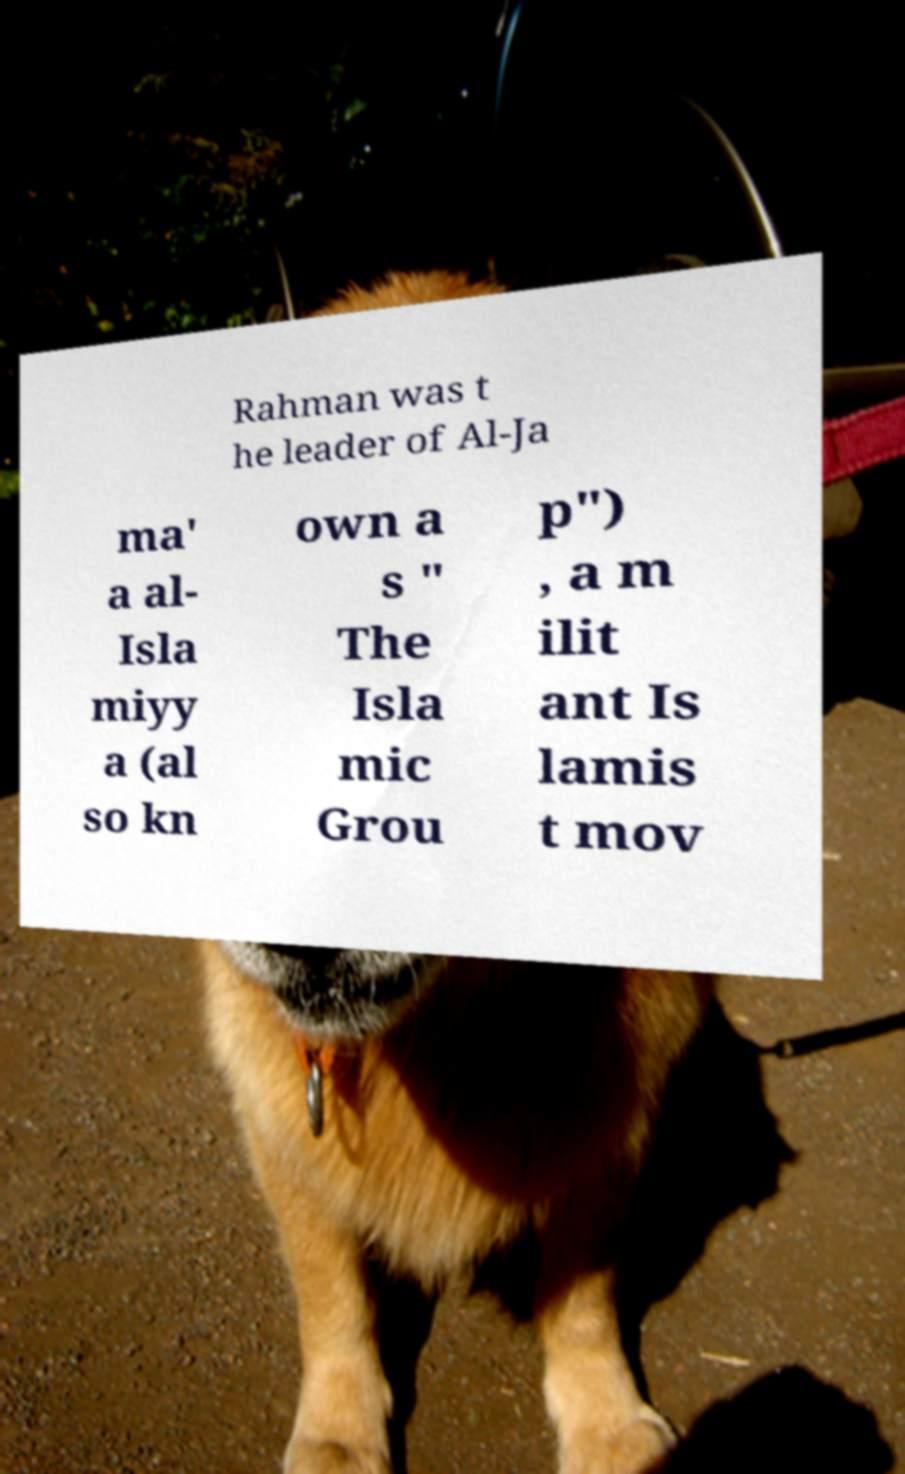There's text embedded in this image that I need extracted. Can you transcribe it verbatim? Rahman was t he leader of Al-Ja ma' a al- Isla miyy a (al so kn own a s " The Isla mic Grou p") , a m ilit ant Is lamis t mov 